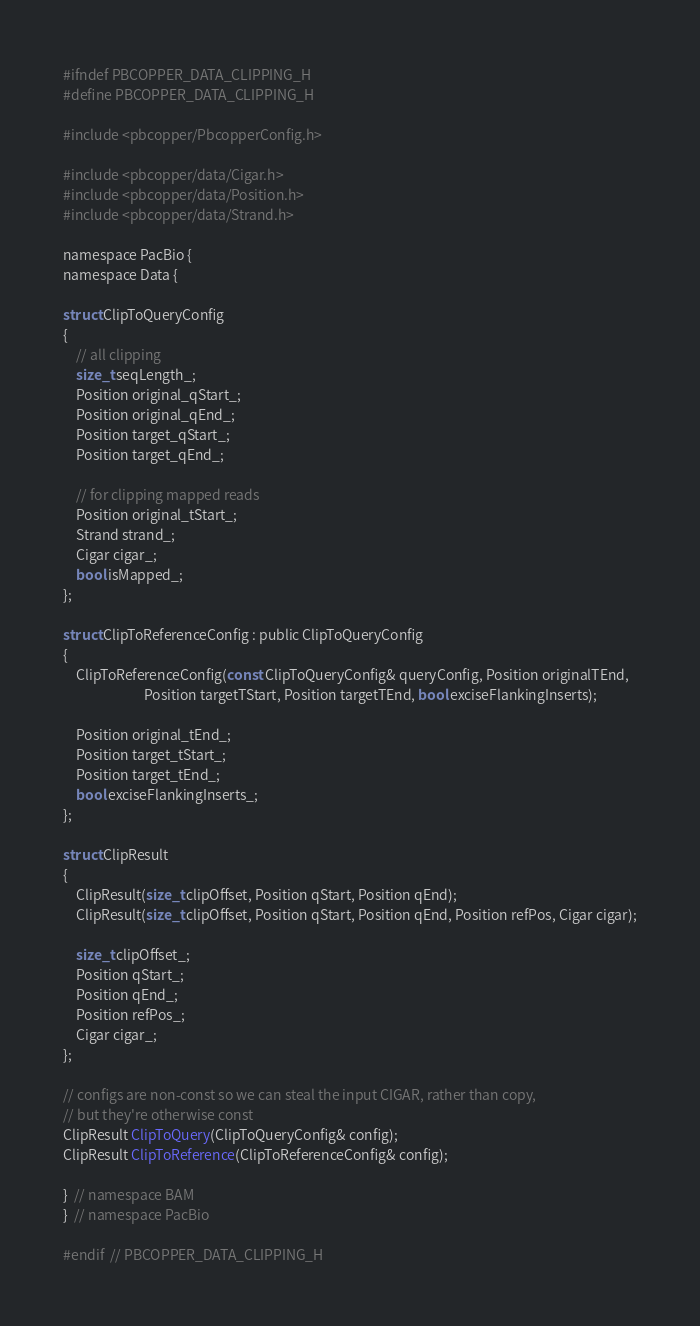Convert code to text. <code><loc_0><loc_0><loc_500><loc_500><_C_>#ifndef PBCOPPER_DATA_CLIPPING_H
#define PBCOPPER_DATA_CLIPPING_H

#include <pbcopper/PbcopperConfig.h>

#include <pbcopper/data/Cigar.h>
#include <pbcopper/data/Position.h>
#include <pbcopper/data/Strand.h>

namespace PacBio {
namespace Data {

struct ClipToQueryConfig
{
    // all clipping
    size_t seqLength_;
    Position original_qStart_;
    Position original_qEnd_;
    Position target_qStart_;
    Position target_qEnd_;

    // for clipping mapped reads
    Position original_tStart_;
    Strand strand_;
    Cigar cigar_;
    bool isMapped_;
};

struct ClipToReferenceConfig : public ClipToQueryConfig
{
    ClipToReferenceConfig(const ClipToQueryConfig& queryConfig, Position originalTEnd,
                          Position targetTStart, Position targetTEnd, bool exciseFlankingInserts);

    Position original_tEnd_;
    Position target_tStart_;
    Position target_tEnd_;
    bool exciseFlankingInserts_;
};

struct ClipResult
{
    ClipResult(size_t clipOffset, Position qStart, Position qEnd);
    ClipResult(size_t clipOffset, Position qStart, Position qEnd, Position refPos, Cigar cigar);

    size_t clipOffset_;
    Position qStart_;
    Position qEnd_;
    Position refPos_;
    Cigar cigar_;
};

// configs are non-const so we can steal the input CIGAR, rather than copy,
// but they're otherwise const
ClipResult ClipToQuery(ClipToQueryConfig& config);
ClipResult ClipToReference(ClipToReferenceConfig& config);

}  // namespace BAM
}  // namespace PacBio

#endif  // PBCOPPER_DATA_CLIPPING_H
</code> 